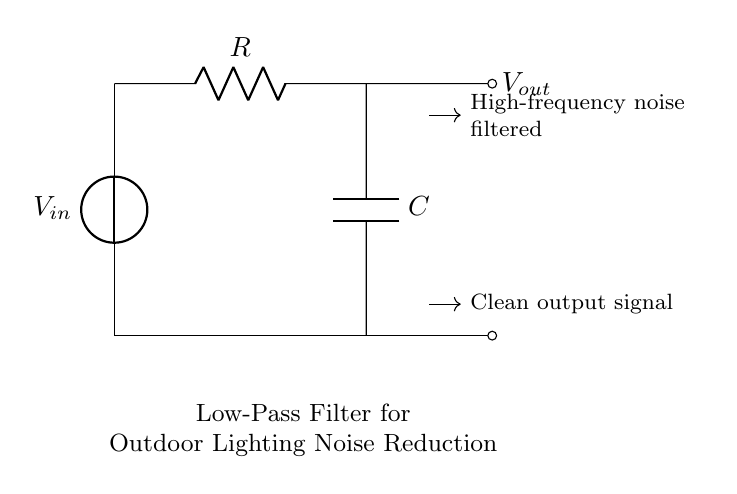What type of filter is represented in this circuit? This circuit diagram depicts a low-pass filter, which allows low-frequency signals to pass while attenuating higher-frequency signals. The presence of a resistor and capacitor in series with the output exemplifies this function.
Answer: low-pass filter What components are used in this circuit? The two main components of the circuit are a resistor and a capacitor. The diagram clearly labels these components, indicating their roles in the filtering process.
Answer: resistor and capacitor What is the output of this low-pass filter? The output of this circuit is the voltage at the output node, which is labeled as Vout. This represents the clean signal after high-frequency noise has been filtered out.
Answer: Vout What signal is being filtered in this circuit? The circuit primarily filters high-frequency noise from the input signal, V_in. This is indicated by the directional arrows showing the reduction of high-frequency components, allowing only cleaner, low-frequency signals to pass through.
Answer: high-frequency noise How does the capacitor affect the circuit? The capacitor works by blocking high-frequency signals while allowing low-frequency signals to pass. It charges and discharges in response to voltage changes, thus smoothing out the output.
Answer: blocks high frequencies What is the connection between the resistor and the capacitor? The resistor and capacitor are connected in series in this low-pass filter configuration. The arrangement allows the resistor to limit the current and the capacitor to store charge, effectively shaping the frequency response of the circuit.
Answer: series connection What happens to high-frequency noise in this circuit? High-frequency noise is attenuated or reduced as it transits through the circuit. The filter is designed to eliminate these unwanted high-frequency signals, resulting in a gentler output waveform.
Answer: attenuated 